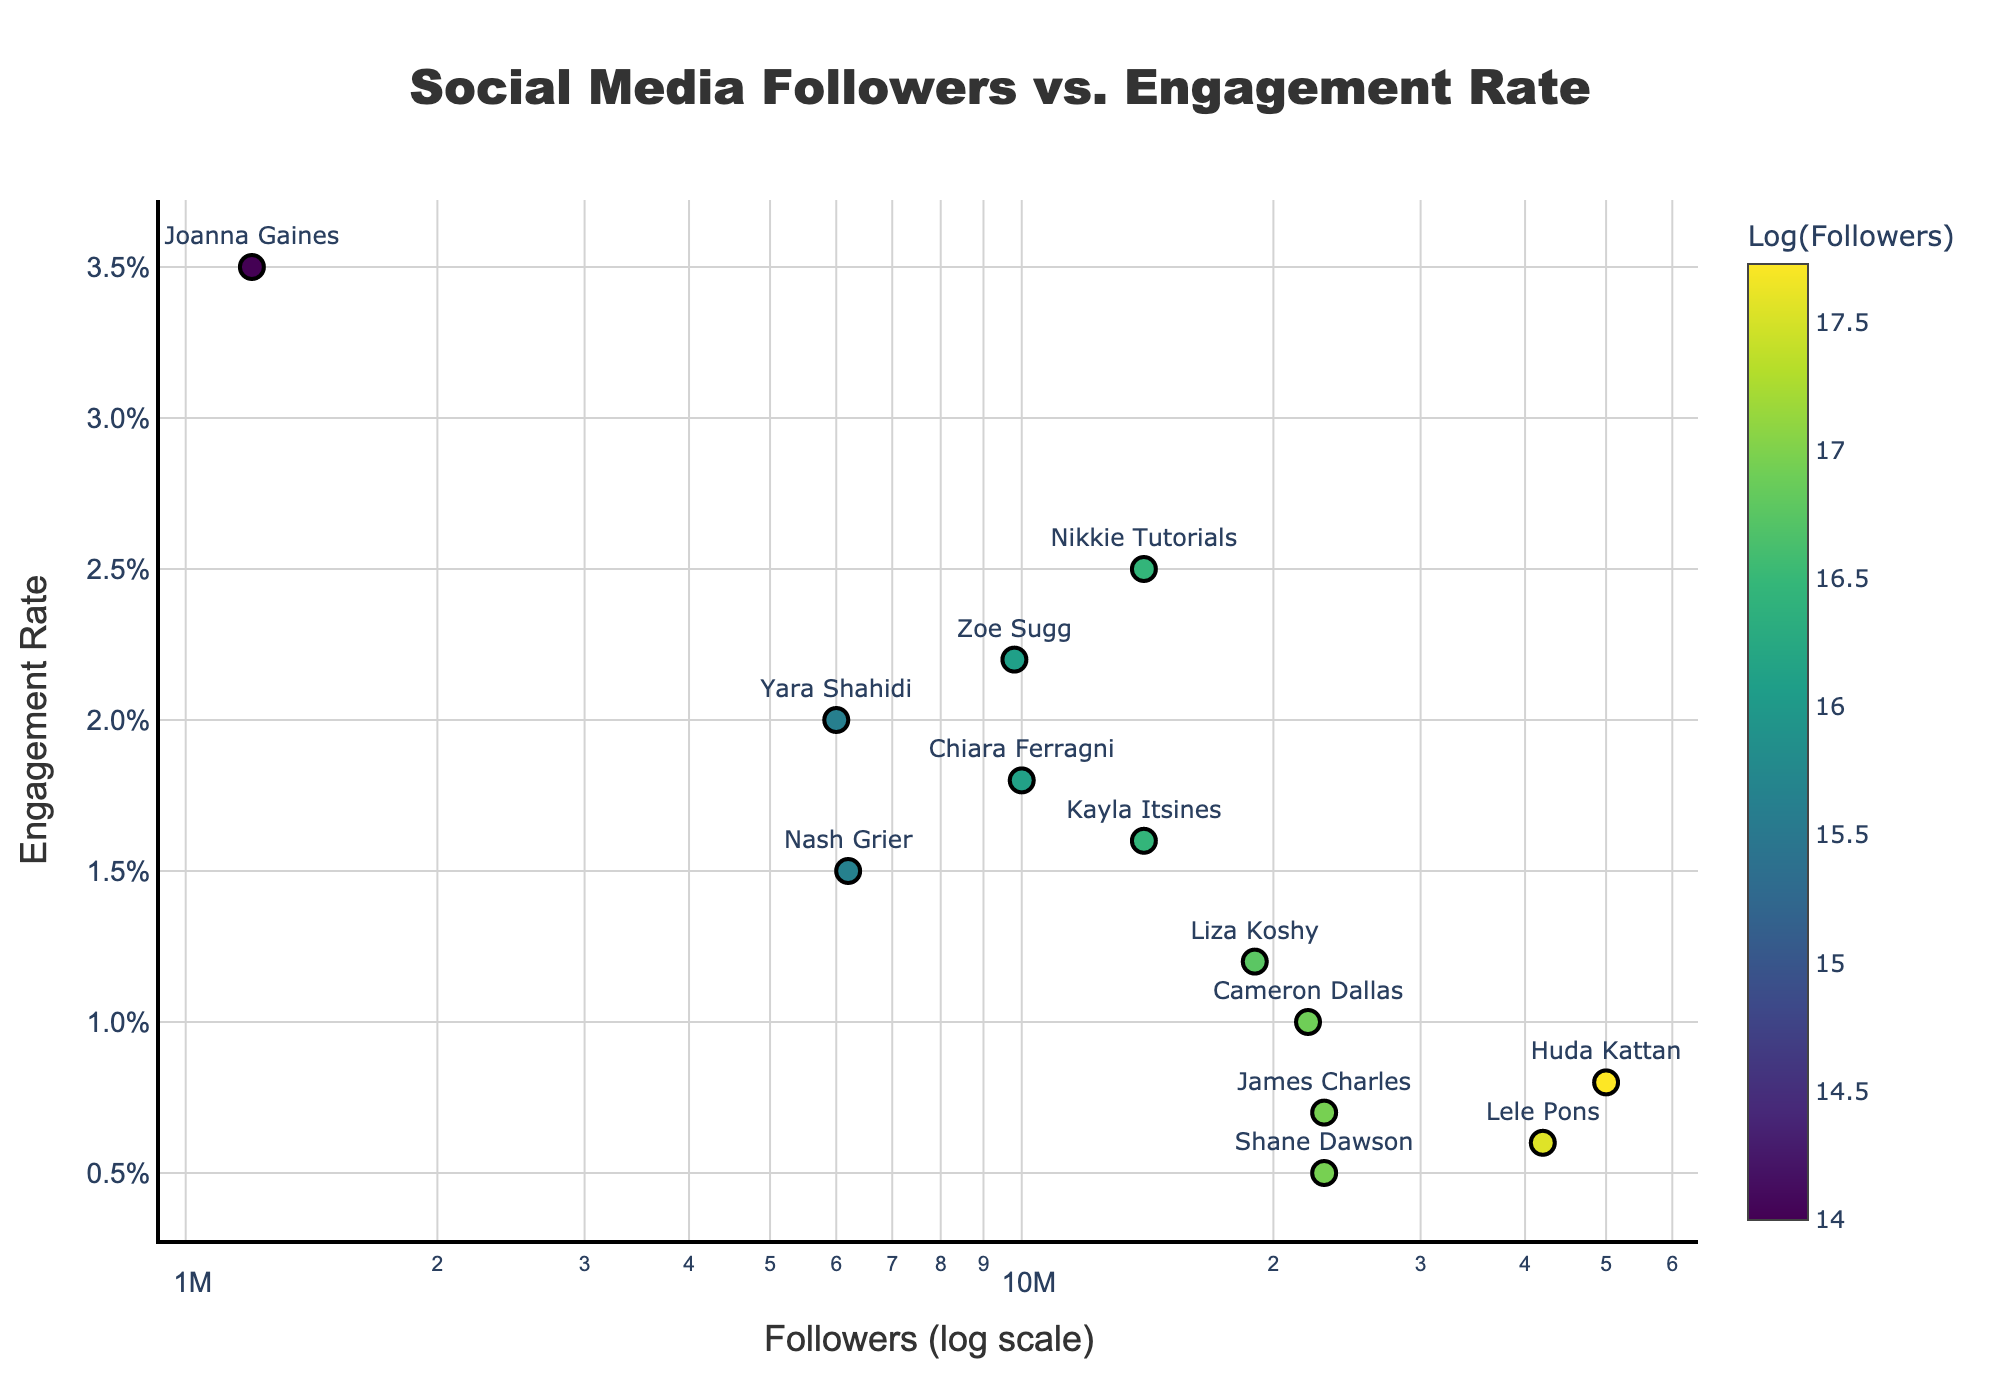How many influencers are represented in the plot? The plot shows data points corresponding to the number of influencers. Each marker represents one influencer. Count the number of unique labels or markers to find the answer.
Answer: 13 What is the title of the plot? The title is usually located at the top of the figure. Read the text displayed there to find the answer.
Answer: Social Media Followers vs. Engagement Rate Which influencer has the highest engagement rate? Look at the y-axis values to determine which data point represents the highest engagement rate, and then use the label or hover information to identify the influencer.
Answer: Joanna Gaines Which influencer has the most followers? Look at the x-axis values to find the data point corresponding to the largest number of followers, and then use the label or hover information to identify the influencer.
Answer: Huda Kattan What is the color scale representing in the plot? The color bar on the right side of the plot indicates it is related to the number of followers. By examining its label, we can determine that it represents the logarithm of followers.
Answer: Log(Followers) How does engagement rate generally vary with the number of followers? Examine the overall distribution of data points across the x (followers) and y (engagement rate) axes to describe the trend.
Answer: Engagement rate generally decreases as the number of followers increases Between Zoe Sugg and Chiara Ferragni, who has a higher engagement rate? Locate the data points for both influencers and compare their y-axis values. The one with the higher y-value (engagement rate) is the answer.
Answer: Zoe Sugg What are the two axes representing? Read the axis titles to understand what each axis represents. The x-axis is labeled "Followers (log scale)" and the y-axis is labeled "Engagement Rate".
Answer: Followers and Engagement Rate What is the engagement rate for Shane Dawson? Find the data point for Shane Dawson and read the corresponding y-axis value.
Answer: 0.005 Which influencer has the lowest engagement rate and how many followers do they have? Locate the data point with the lowest y-axis value and then identify the influencer and their corresponding x-axis (followers) value.
Answer: Shane Dawson, 23,000,000 